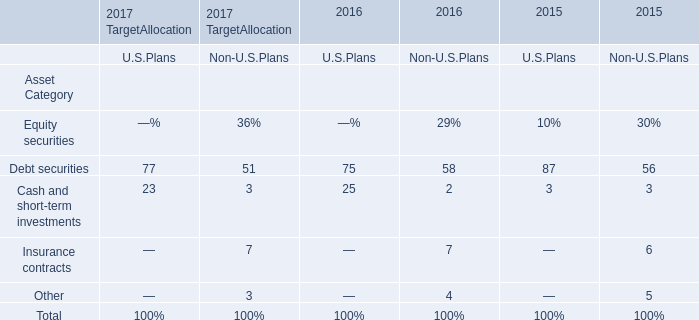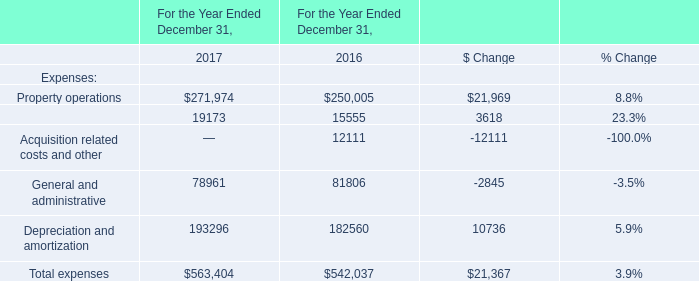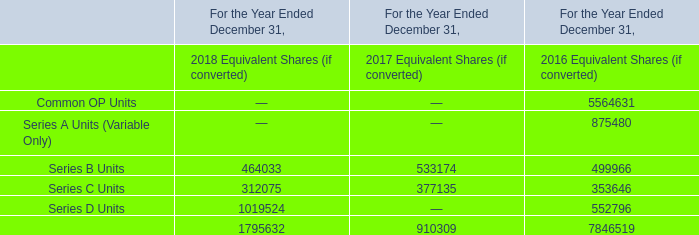What was the average value of the General and administrative and Depreciation and amortization in the years where Property operations is positive? 
Computations: ((78961 + 193296) / 2)
Answer: 136128.5. 